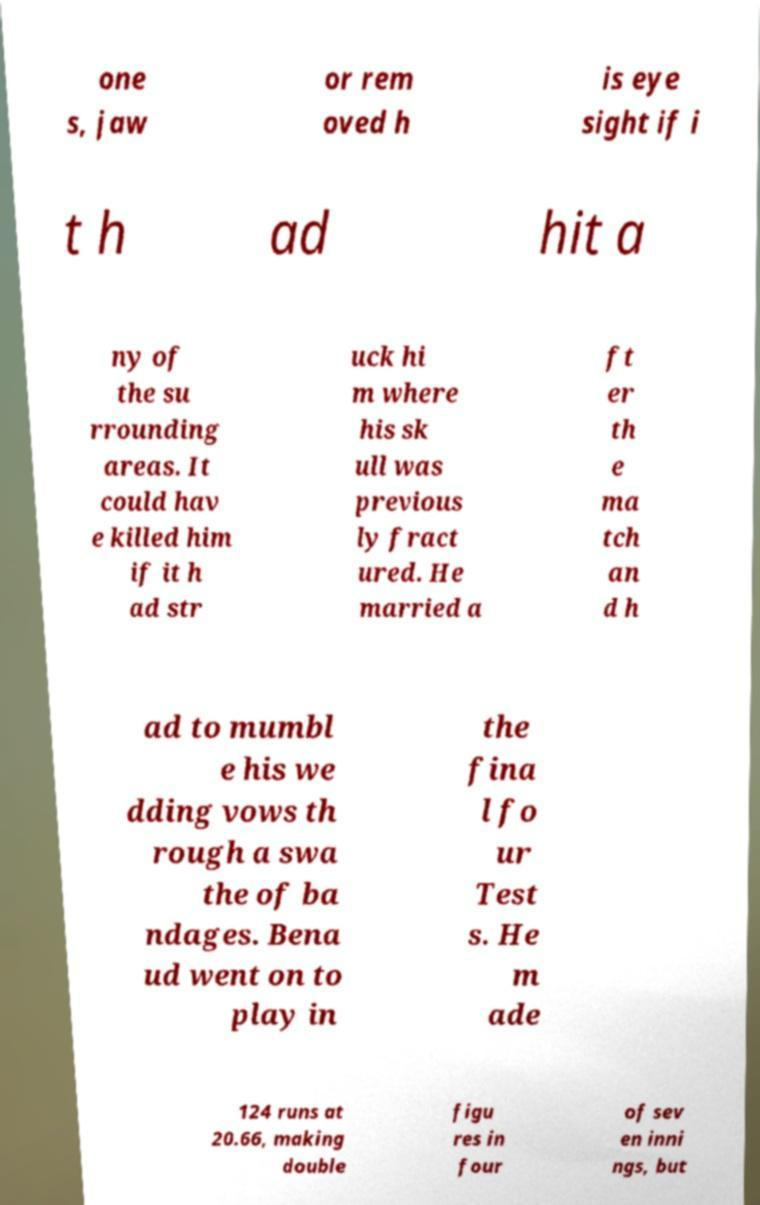For documentation purposes, I need the text within this image transcribed. Could you provide that? one s, jaw or rem oved h is eye sight if i t h ad hit a ny of the su rrounding areas. It could hav e killed him if it h ad str uck hi m where his sk ull was previous ly fract ured. He married a ft er th e ma tch an d h ad to mumbl e his we dding vows th rough a swa the of ba ndages. Bena ud went on to play in the fina l fo ur Test s. He m ade 124 runs at 20.66, making double figu res in four of sev en inni ngs, but 